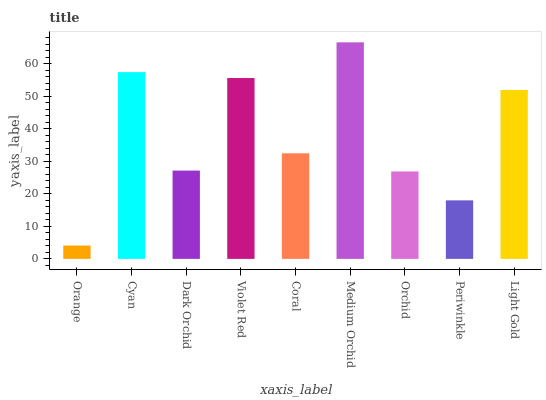Is Orange the minimum?
Answer yes or no. Yes. Is Medium Orchid the maximum?
Answer yes or no. Yes. Is Cyan the minimum?
Answer yes or no. No. Is Cyan the maximum?
Answer yes or no. No. Is Cyan greater than Orange?
Answer yes or no. Yes. Is Orange less than Cyan?
Answer yes or no. Yes. Is Orange greater than Cyan?
Answer yes or no. No. Is Cyan less than Orange?
Answer yes or no. No. Is Coral the high median?
Answer yes or no. Yes. Is Coral the low median?
Answer yes or no. Yes. Is Orchid the high median?
Answer yes or no. No. Is Dark Orchid the low median?
Answer yes or no. No. 